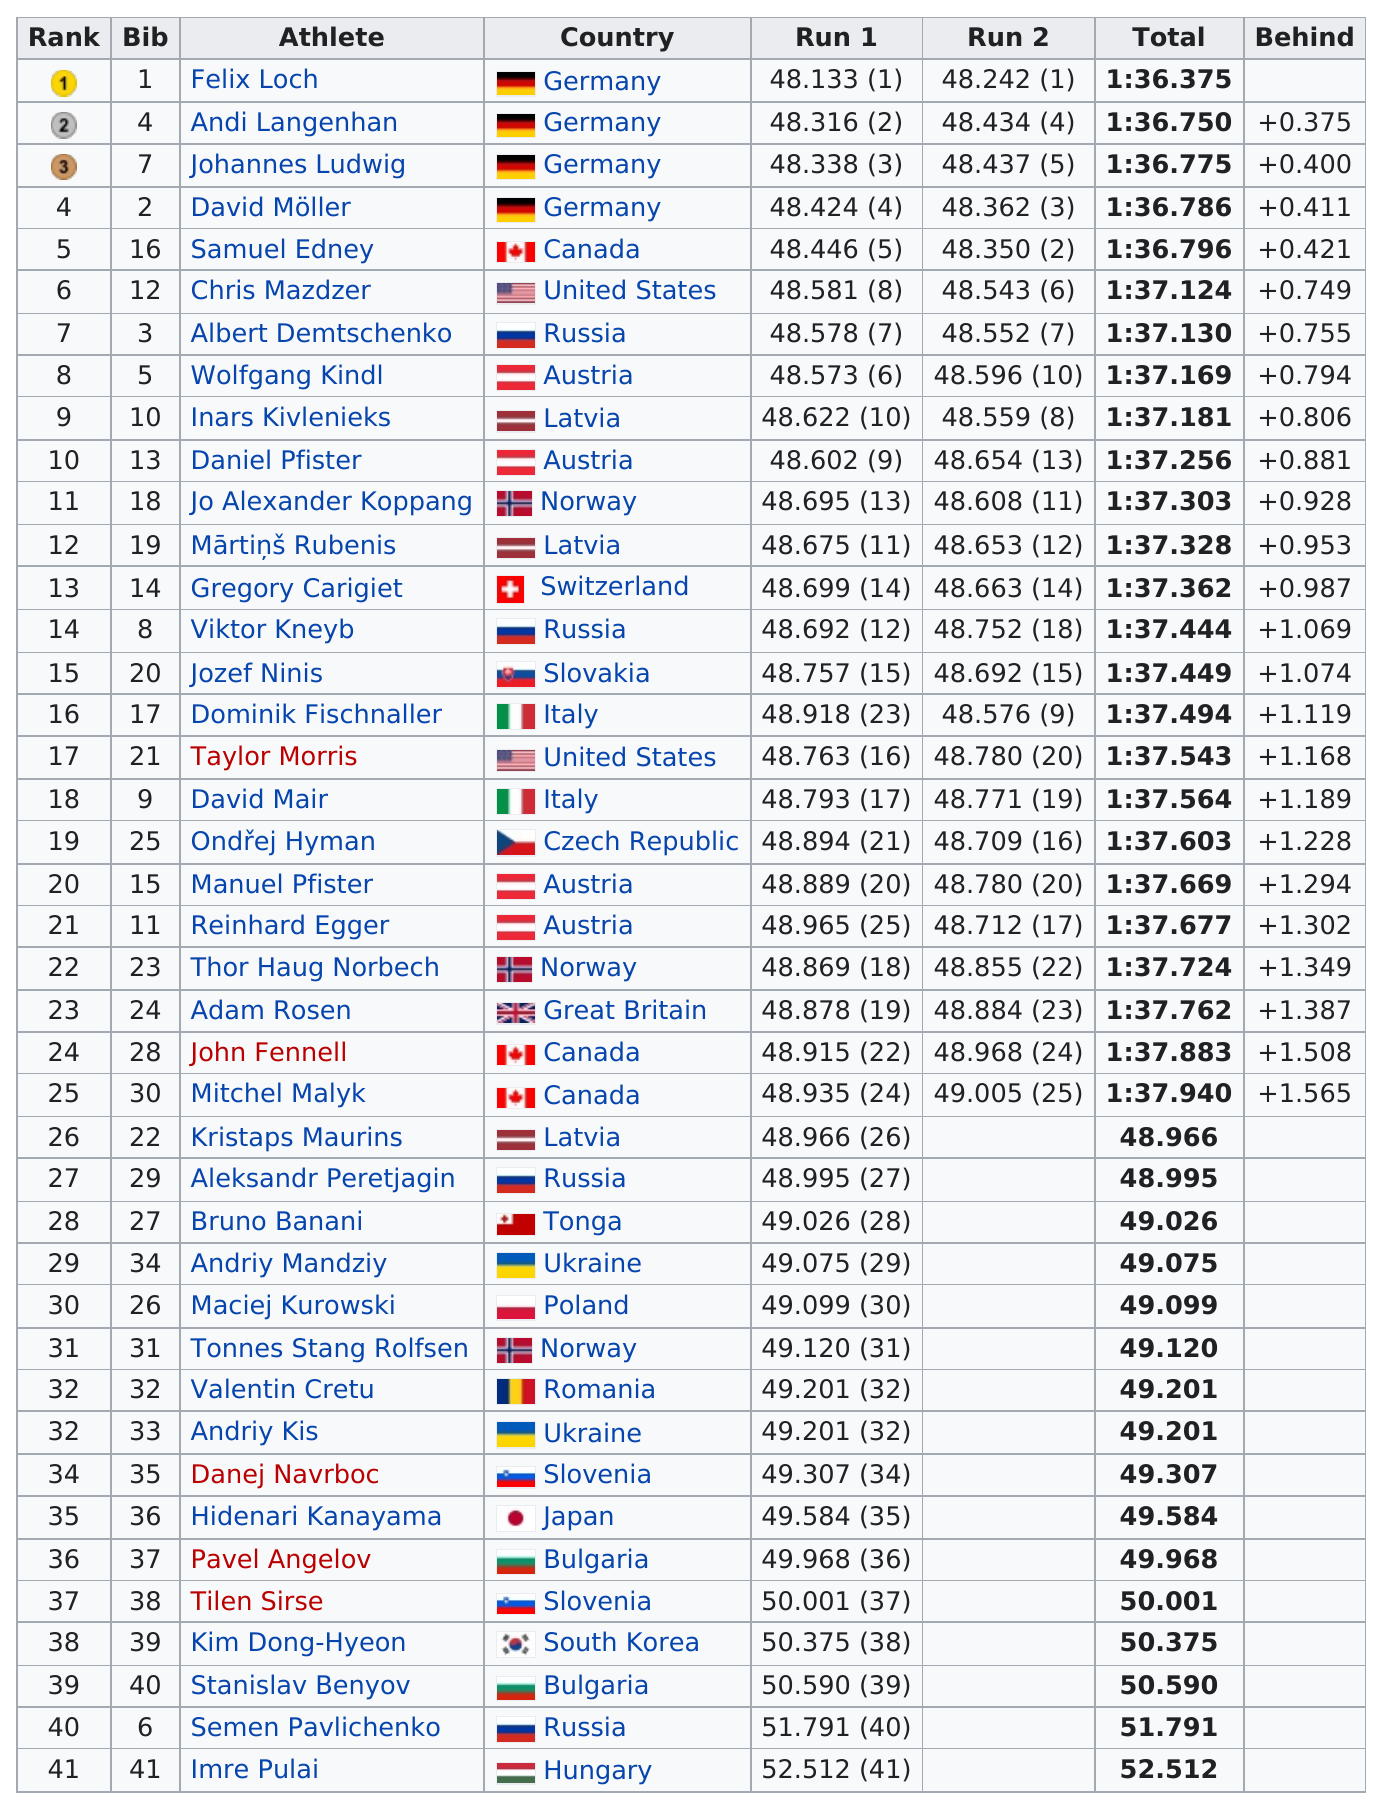Give some essential details in this illustration. There were a total of 41 competitors. Andi Langenhan finished after Felix Loch. Daniel Pfister was behind first place by 0.881... units. David Möller finished before Samuel Edney. Andi Langenhan was the person who finished next after Felix Loch. 